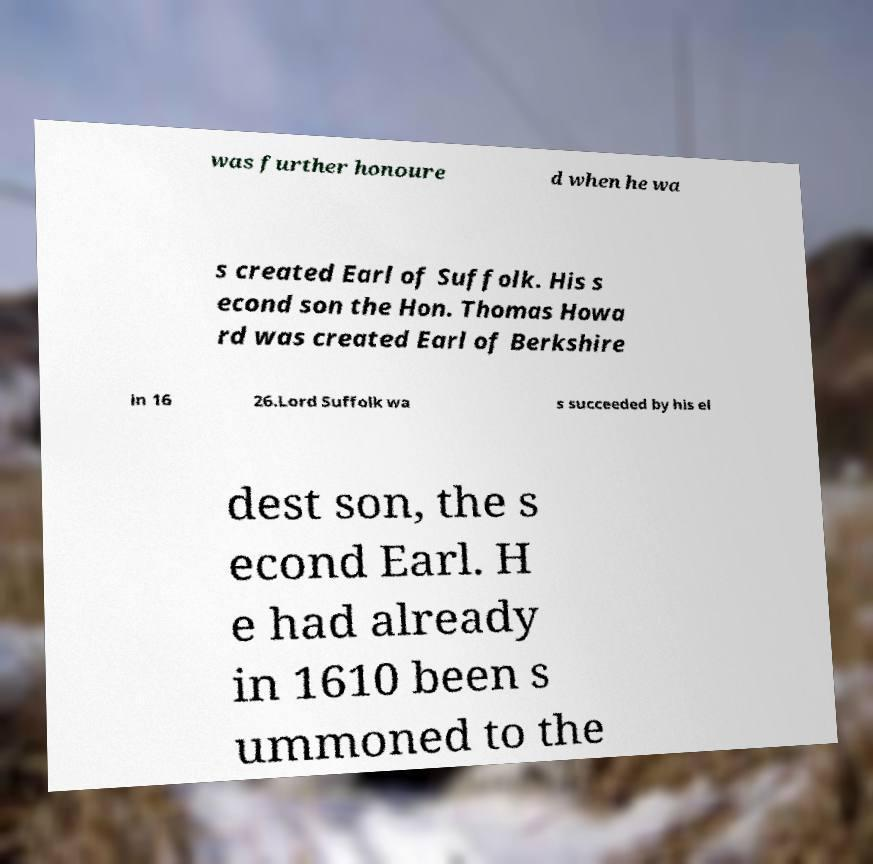There's text embedded in this image that I need extracted. Can you transcribe it verbatim? was further honoure d when he wa s created Earl of Suffolk. His s econd son the Hon. Thomas Howa rd was created Earl of Berkshire in 16 26.Lord Suffolk wa s succeeded by his el dest son, the s econd Earl. H e had already in 1610 been s ummoned to the 